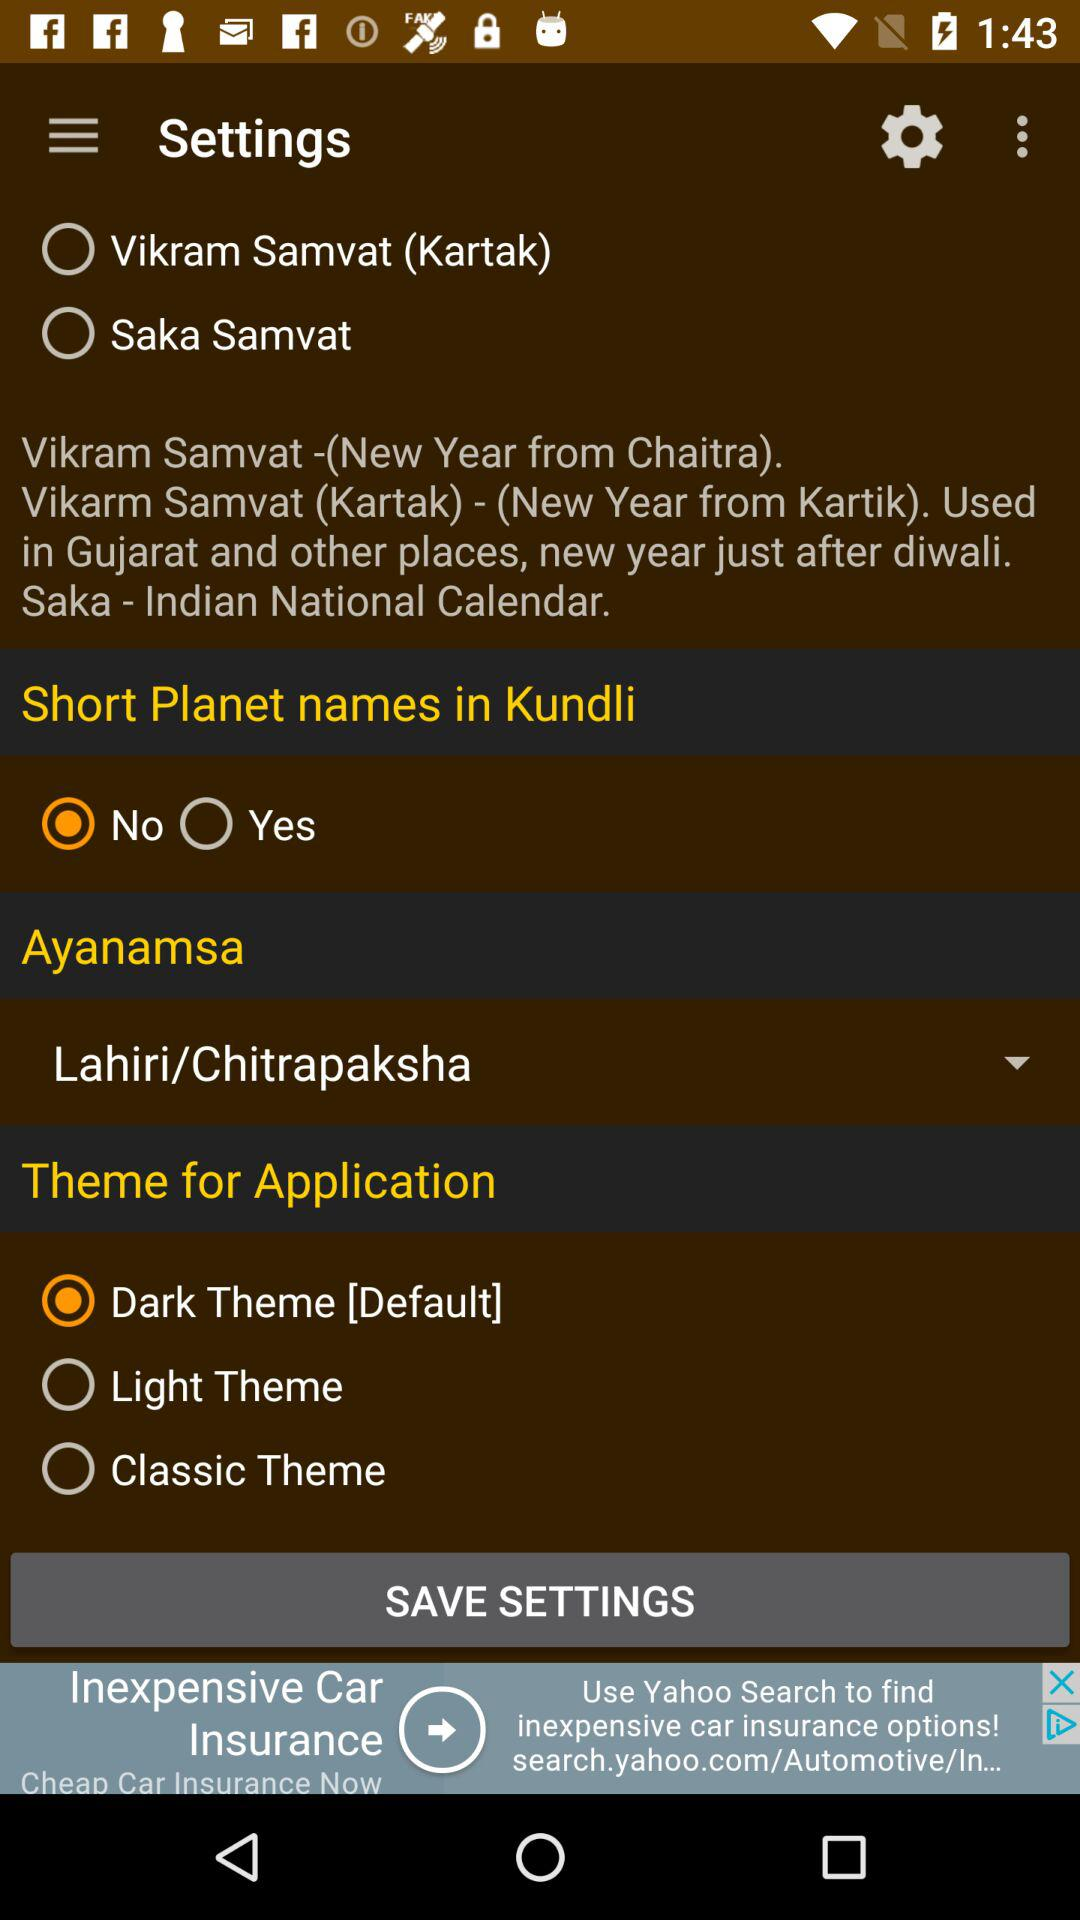What is the month of the new year in Vikram Samvat used in Gujarat and other states? The month of the new year in Vikram Samvat used in Gujarat and other states is Kartak. 